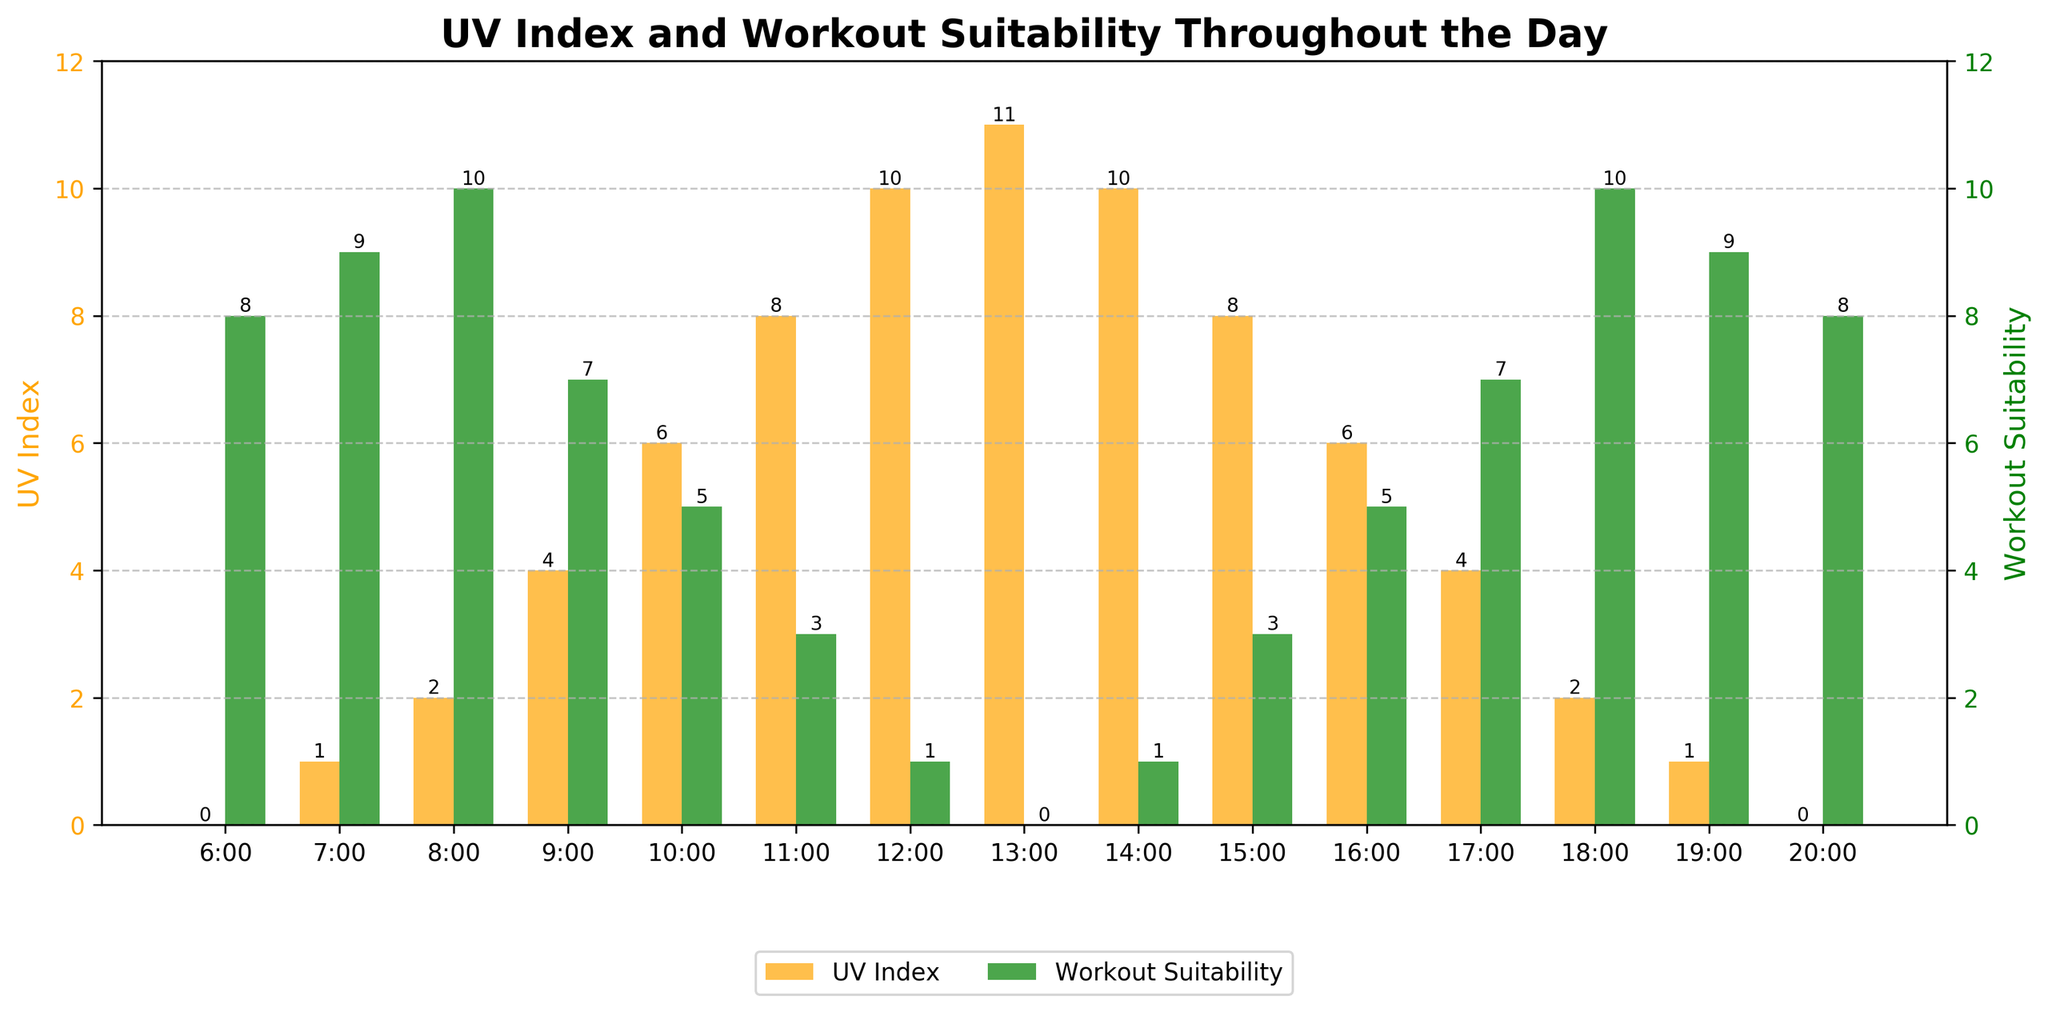What's the time of day with the highest UV Index? The bar for UV Index is highest at 13:00, reaching a value of 11.
Answer: 13:00 Which time has the highest workout suitability? The bar for Workout Suitability is highest at 8:00 and 18:00, both reaching a value of 10.
Answer: 8:00, 18:00 Compare the UV Index at 9:00 with the Workout Suitability at the same time. At 9:00, the UV Index bar is at 4 and the Workout Suitability bar is at 7.
Answer: UV Index: 4, Workout Suitability: 7 What is the general trend of the UV Index from 6:00 to 13:00? From 6:00 to 13:00, the UV Index increases, peaking at 13:00 with a value of 11.
Answer: Increasing Which time period(s) show(s) an equal UV Index and Workout Suitability? Compare the values of UV Index and Workout Suitability at each time; they are never equal.
Answer: None What is the total Workout Suitability score from 6:00 to 20:00? Summing the Workout Suitability values: 8 + 9 + 10 + 7 + 5 + 3 + 1 + 0 + 1 + 3 + 5 + 7 + 10 + 9 + 8 = 86.
Answer: 86 At what times is the UV Index less than or equal to 2? Identifying times with UV Index ≤ 2: 6:00, 7:00, 8:00, 18:00, 19:00, 20:00.
Answer: 6:00, 7:00, 8:00, 18:00, 19:00, 20:00 Which time has the steepest drop in Workout Suitability compared to its previous time interval? The steepest drop in Workout Suitability occurs between 8:00 (10) and 9:00 (7), with a difference of 3.
Answer: 9:00 